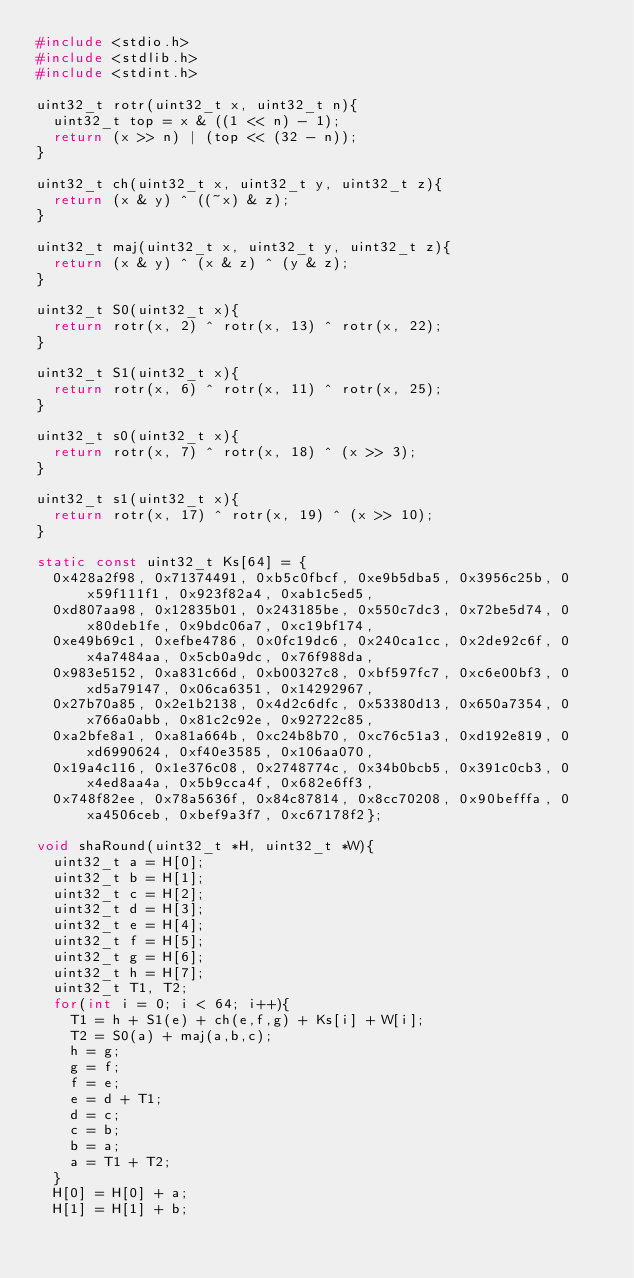Convert code to text. <code><loc_0><loc_0><loc_500><loc_500><_C_>#include <stdio.h>
#include <stdlib.h>
#include <stdint.h>

uint32_t rotr(uint32_t x, uint32_t n){
  uint32_t top = x & ((1 << n) - 1);
  return (x >> n) | (top << (32 - n)); 
}

uint32_t ch(uint32_t x, uint32_t y, uint32_t z){
  return (x & y) ^ ((~x) & z);
}

uint32_t maj(uint32_t x, uint32_t y, uint32_t z){
  return (x & y) ^ (x & z) ^ (y & z);
}

uint32_t S0(uint32_t x){
  return rotr(x, 2) ^ rotr(x, 13) ^ rotr(x, 22);
}

uint32_t S1(uint32_t x){
  return rotr(x, 6) ^ rotr(x, 11) ^ rotr(x, 25);
}

uint32_t s0(uint32_t x){
  return rotr(x, 7) ^ rotr(x, 18) ^ (x >> 3);
}

uint32_t s1(uint32_t x){
  return rotr(x, 17) ^ rotr(x, 19) ^ (x >> 10);
}

static const uint32_t Ks[64] = {
  0x428a2f98, 0x71374491, 0xb5c0fbcf, 0xe9b5dba5, 0x3956c25b, 0x59f111f1, 0x923f82a4, 0xab1c5ed5,
  0xd807aa98, 0x12835b01, 0x243185be, 0x550c7dc3, 0x72be5d74, 0x80deb1fe, 0x9bdc06a7, 0xc19bf174,
  0xe49b69c1, 0xefbe4786, 0x0fc19dc6, 0x240ca1cc, 0x2de92c6f, 0x4a7484aa, 0x5cb0a9dc, 0x76f988da,
  0x983e5152, 0xa831c66d, 0xb00327c8, 0xbf597fc7, 0xc6e00bf3, 0xd5a79147, 0x06ca6351, 0x14292967,
  0x27b70a85, 0x2e1b2138, 0x4d2c6dfc, 0x53380d13, 0x650a7354, 0x766a0abb, 0x81c2c92e, 0x92722c85,
  0xa2bfe8a1, 0xa81a664b, 0xc24b8b70, 0xc76c51a3, 0xd192e819, 0xd6990624, 0xf40e3585, 0x106aa070,
  0x19a4c116, 0x1e376c08, 0x2748774c, 0x34b0bcb5, 0x391c0cb3, 0x4ed8aa4a, 0x5b9cca4f, 0x682e6ff3,
  0x748f82ee, 0x78a5636f, 0x84c87814, 0x8cc70208, 0x90befffa, 0xa4506ceb, 0xbef9a3f7, 0xc67178f2};

void shaRound(uint32_t *H, uint32_t *W){
  uint32_t a = H[0];
  uint32_t b = H[1];
  uint32_t c = H[2];
  uint32_t d = H[3];
  uint32_t e = H[4];
  uint32_t f = H[5];
  uint32_t g = H[6];
  uint32_t h = H[7];
  uint32_t T1, T2;
  for(int i = 0; i < 64; i++){
    T1 = h + S1(e) + ch(e,f,g) + Ks[i] + W[i];
    T2 = S0(a) + maj(a,b,c);
    h = g;
    g = f;
    f = e;
    e = d + T1;
    d = c;
    c = b;
    b = a;
    a = T1 + T2;
  }
  H[0] = H[0] + a;
  H[1] = H[1] + b;</code> 